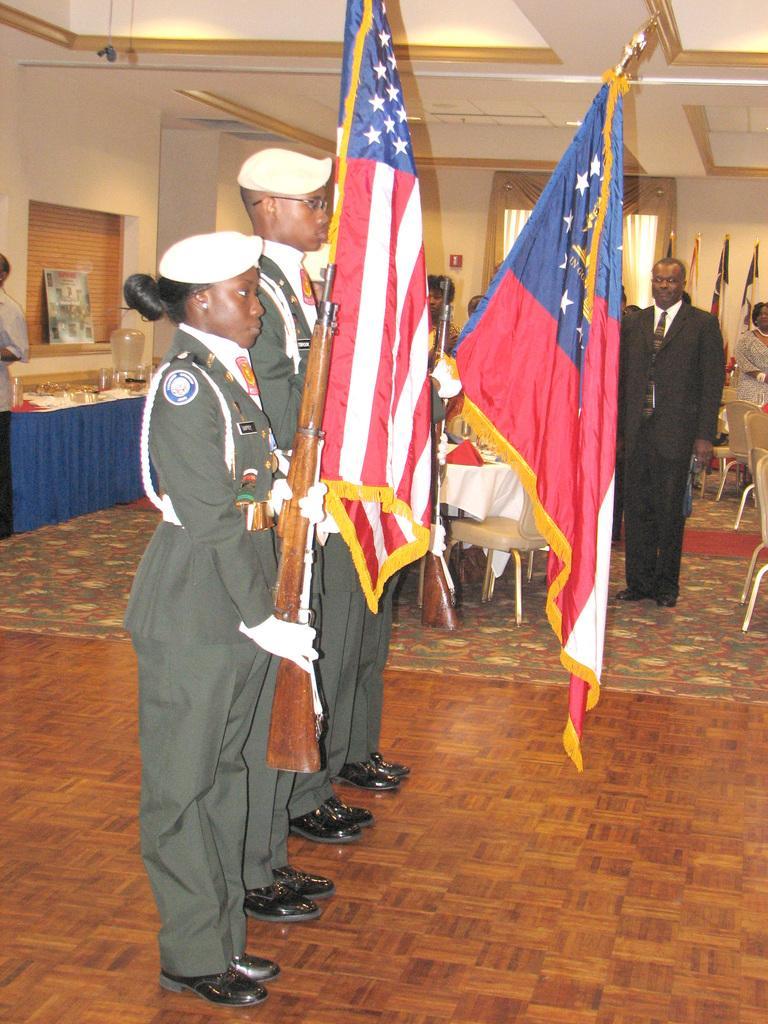Describe this image in one or two sentences. In the picture we can see a man and a woman standing in uniforms, holding guns and flags in their hands and beside them we can see some people are also standing and we can see man standing in blazer, tie near to him we can see a table with white cloth and behind them we can see some chairs and some flags near the wall and on the other side of the wall we can see a table with blue color cloth on it. 